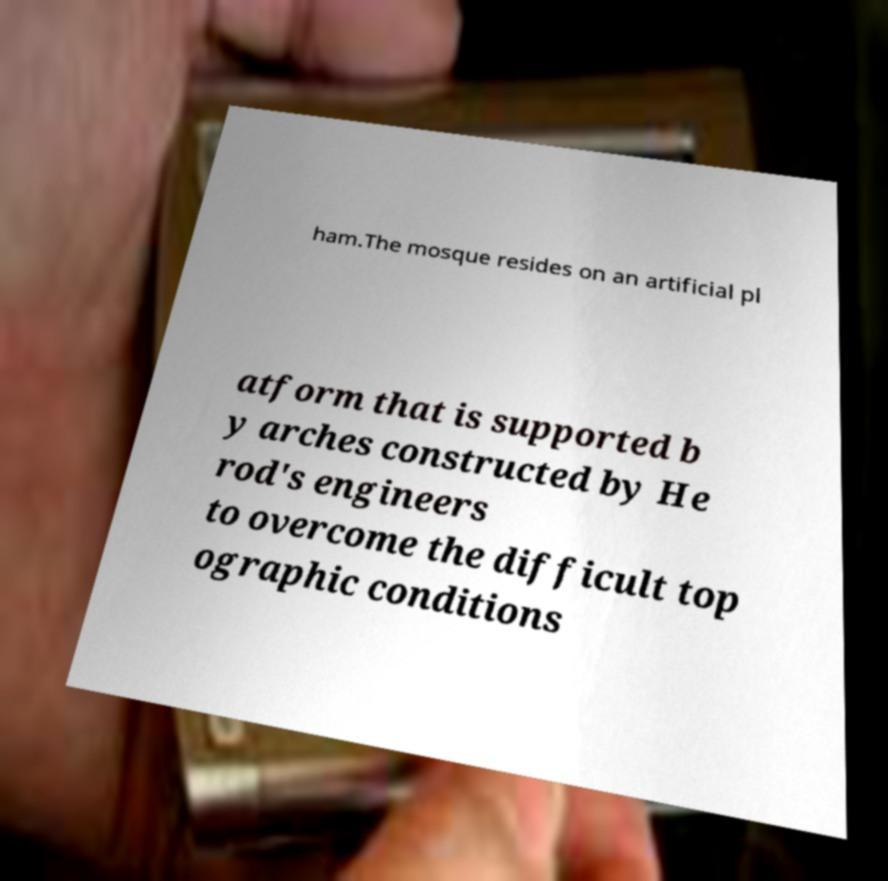For documentation purposes, I need the text within this image transcribed. Could you provide that? ham.The mosque resides on an artificial pl atform that is supported b y arches constructed by He rod's engineers to overcome the difficult top ographic conditions 